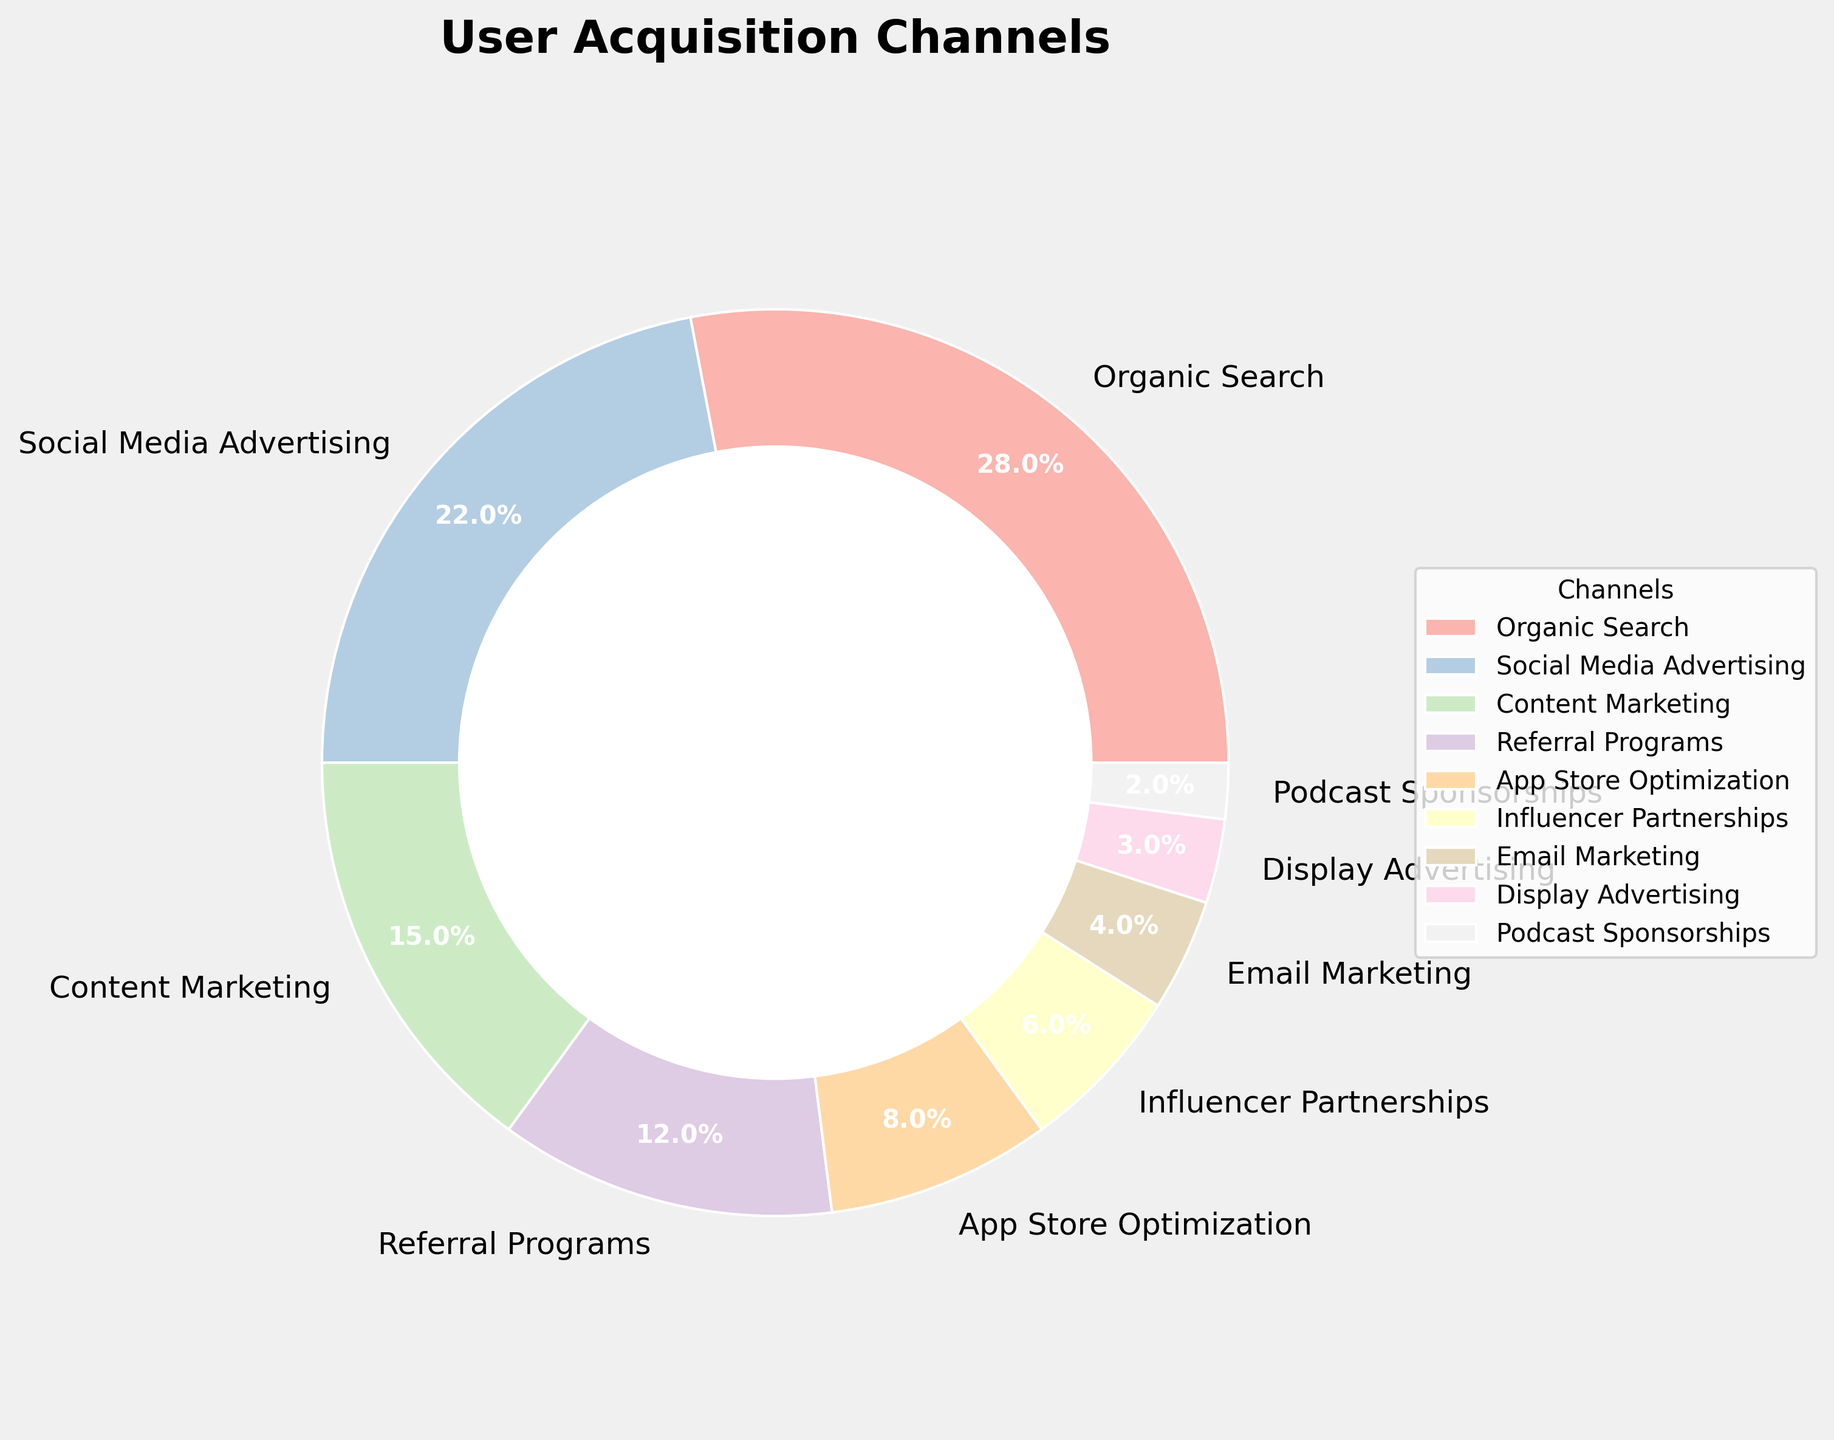What is the highest user acquisition channel in the chart? Look at the chart and find the wedge with the largest size, which is "Organic Search" at 28%.
Answer: Organic Search What is the combined percentage of Social Media Advertising and Content Marketing? Locate the percentages for Social Media Advertising (22%) and Content Marketing (15%), then sum these values: 22 + 15 = 37.
Answer: 37% Which channel has a higher percentage, Referral Programs or Influencer Partnerships? Compare the percentages of Referral Programs (12%) and Influencer Partnerships (6%). Referral Programs is higher.
Answer: Referral Programs What is the percentage difference between Organic Search and App Store Optimization? Identify the percentages for Organic Search (28%) and App Store Optimization (8%). Calculate the difference: 28 - 8 = 20.
Answer: 20% How many channels have a user acquisition percentage less than 10%? Count the channels with percentages below 10%: App Store Optimization (8%), Influencer Partnerships (6%), Email Marketing (4%), Display Advertising (3%), Podcast Sponsorships (2%). There are 5 such channels.
Answer: 5 What percentage of users were acquired through Referral Programs and Display Advertising combined? Locate the percentages for Referral Programs (12%) and Display Advertising (3%), then sum them: 12 + 3 = 15.
Answer: 15% Which channel has the smallest percentage of user acquisition? Look at the smallest wedge in the chart, which represents Podcast Sponsorships at 2%.
Answer: Podcast Sponsorships What is the visual color for the Email Marketing wedge in the pie chart? Identify the wedge labeled "Email Marketing" and note its color, which typically comes from the custom color palette generated. In this case, it's important to mention the specific color palette might need viewing, but usually, pastel colors have light shades.
Answer: Light pastel color Are there more users acquired through Social Media Advertising or Content Marketing? Compare the percentages of Social Media Advertising (22%) and Content Marketing (15%). Social Media Advertising has a higher percentage.
Answer: Social Media Advertising What is the second largest user acquisition channel? Determine the channel with the second-largest wedge, which is Social Media Advertising at 22%.
Answer: Social Media Advertising 